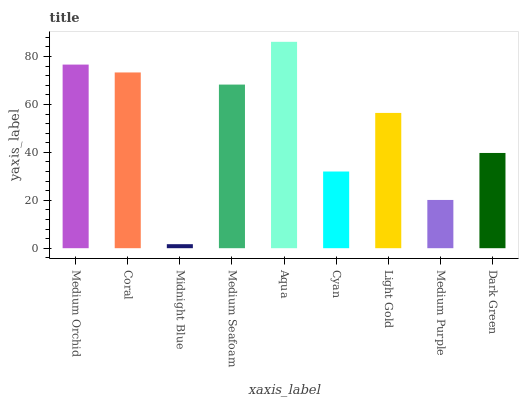Is Midnight Blue the minimum?
Answer yes or no. Yes. Is Aqua the maximum?
Answer yes or no. Yes. Is Coral the minimum?
Answer yes or no. No. Is Coral the maximum?
Answer yes or no. No. Is Medium Orchid greater than Coral?
Answer yes or no. Yes. Is Coral less than Medium Orchid?
Answer yes or no. Yes. Is Coral greater than Medium Orchid?
Answer yes or no. No. Is Medium Orchid less than Coral?
Answer yes or no. No. Is Light Gold the high median?
Answer yes or no. Yes. Is Light Gold the low median?
Answer yes or no. Yes. Is Cyan the high median?
Answer yes or no. No. Is Cyan the low median?
Answer yes or no. No. 